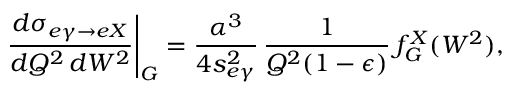Convert formula to latex. <formula><loc_0><loc_0><loc_500><loc_500>\frac { d \sigma _ { e \gamma \to e X } } { d Q ^ { 2 } \, d W ^ { 2 } } \right | _ { G } = \frac { \alpha ^ { 3 } } { 4 s _ { e \gamma } ^ { 2 } } \, \frac { 1 } { Q ^ { 2 } ( 1 - \epsilon ) } \, f _ { G } ^ { X } ( W ^ { 2 } ) ,</formula> 